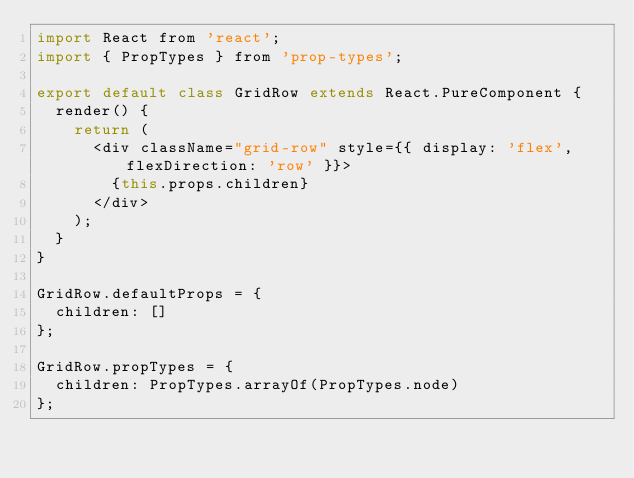<code> <loc_0><loc_0><loc_500><loc_500><_JavaScript_>import React from 'react';
import { PropTypes } from 'prop-types';

export default class GridRow extends React.PureComponent {
  render() {
    return (
      <div className="grid-row" style={{ display: 'flex', flexDirection: 'row' }}>
        {this.props.children}
      </div>
    );
  }
}

GridRow.defaultProps = {
  children: []
};

GridRow.propTypes = {
  children: PropTypes.arrayOf(PropTypes.node)
};
</code> 